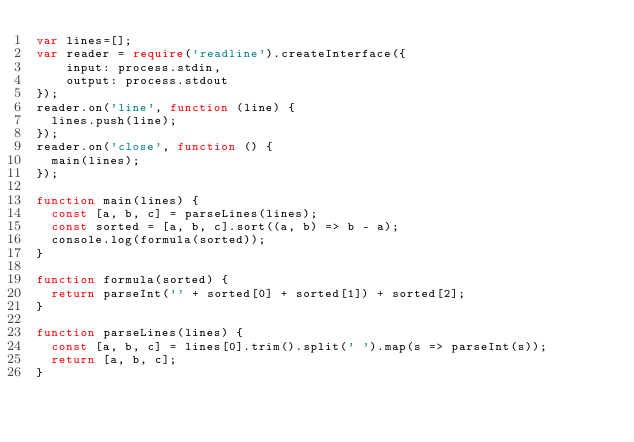Convert code to text. <code><loc_0><loc_0><loc_500><loc_500><_TypeScript_>var lines=[];
var reader = require('readline').createInterface({
    input: process.stdin,
    output: process.stdout
});
reader.on('line', function (line) {
  lines.push(line);
});
reader.on('close', function () {
  main(lines);
});

function main(lines) {
  const [a, b, c] = parseLines(lines);  
  const sorted = [a, b, c].sort((a, b) => b - a);
  console.log(formula(sorted));
}

function formula(sorted) {
  return parseInt('' + sorted[0] + sorted[1]) + sorted[2];
}

function parseLines(lines) {
  const [a, b, c] = lines[0].trim().split(' ').map(s => parseInt(s));
  return [a, b, c];
}
</code> 